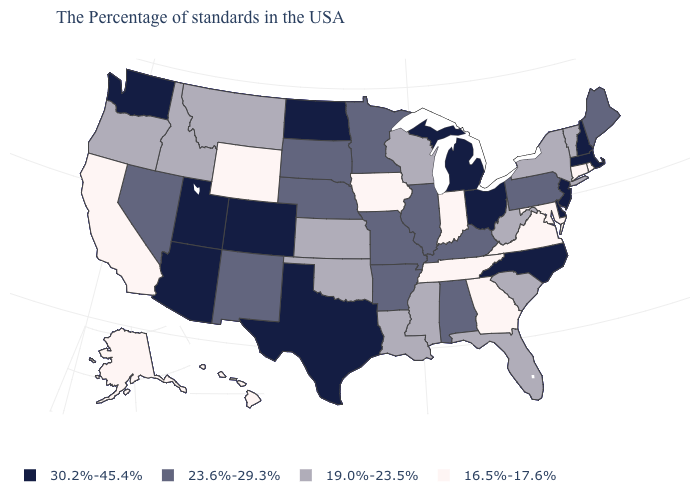Does Utah have the lowest value in the USA?
Write a very short answer. No. What is the value of Washington?
Be succinct. 30.2%-45.4%. Is the legend a continuous bar?
Answer briefly. No. What is the value of Massachusetts?
Answer briefly. 30.2%-45.4%. Name the states that have a value in the range 23.6%-29.3%?
Write a very short answer. Maine, Pennsylvania, Kentucky, Alabama, Illinois, Missouri, Arkansas, Minnesota, Nebraska, South Dakota, New Mexico, Nevada. What is the value of New Mexico?
Be succinct. 23.6%-29.3%. Name the states that have a value in the range 16.5%-17.6%?
Be succinct. Rhode Island, Connecticut, Maryland, Virginia, Georgia, Indiana, Tennessee, Iowa, Wyoming, California, Alaska, Hawaii. Name the states that have a value in the range 30.2%-45.4%?
Short answer required. Massachusetts, New Hampshire, New Jersey, Delaware, North Carolina, Ohio, Michigan, Texas, North Dakota, Colorado, Utah, Arizona, Washington. Which states have the lowest value in the West?
Short answer required. Wyoming, California, Alaska, Hawaii. What is the lowest value in the USA?
Concise answer only. 16.5%-17.6%. What is the value of Montana?
Give a very brief answer. 19.0%-23.5%. What is the value of Delaware?
Be succinct. 30.2%-45.4%. Among the states that border New Jersey , which have the highest value?
Concise answer only. Delaware. Does the first symbol in the legend represent the smallest category?
Be succinct. No. How many symbols are there in the legend?
Give a very brief answer. 4. 